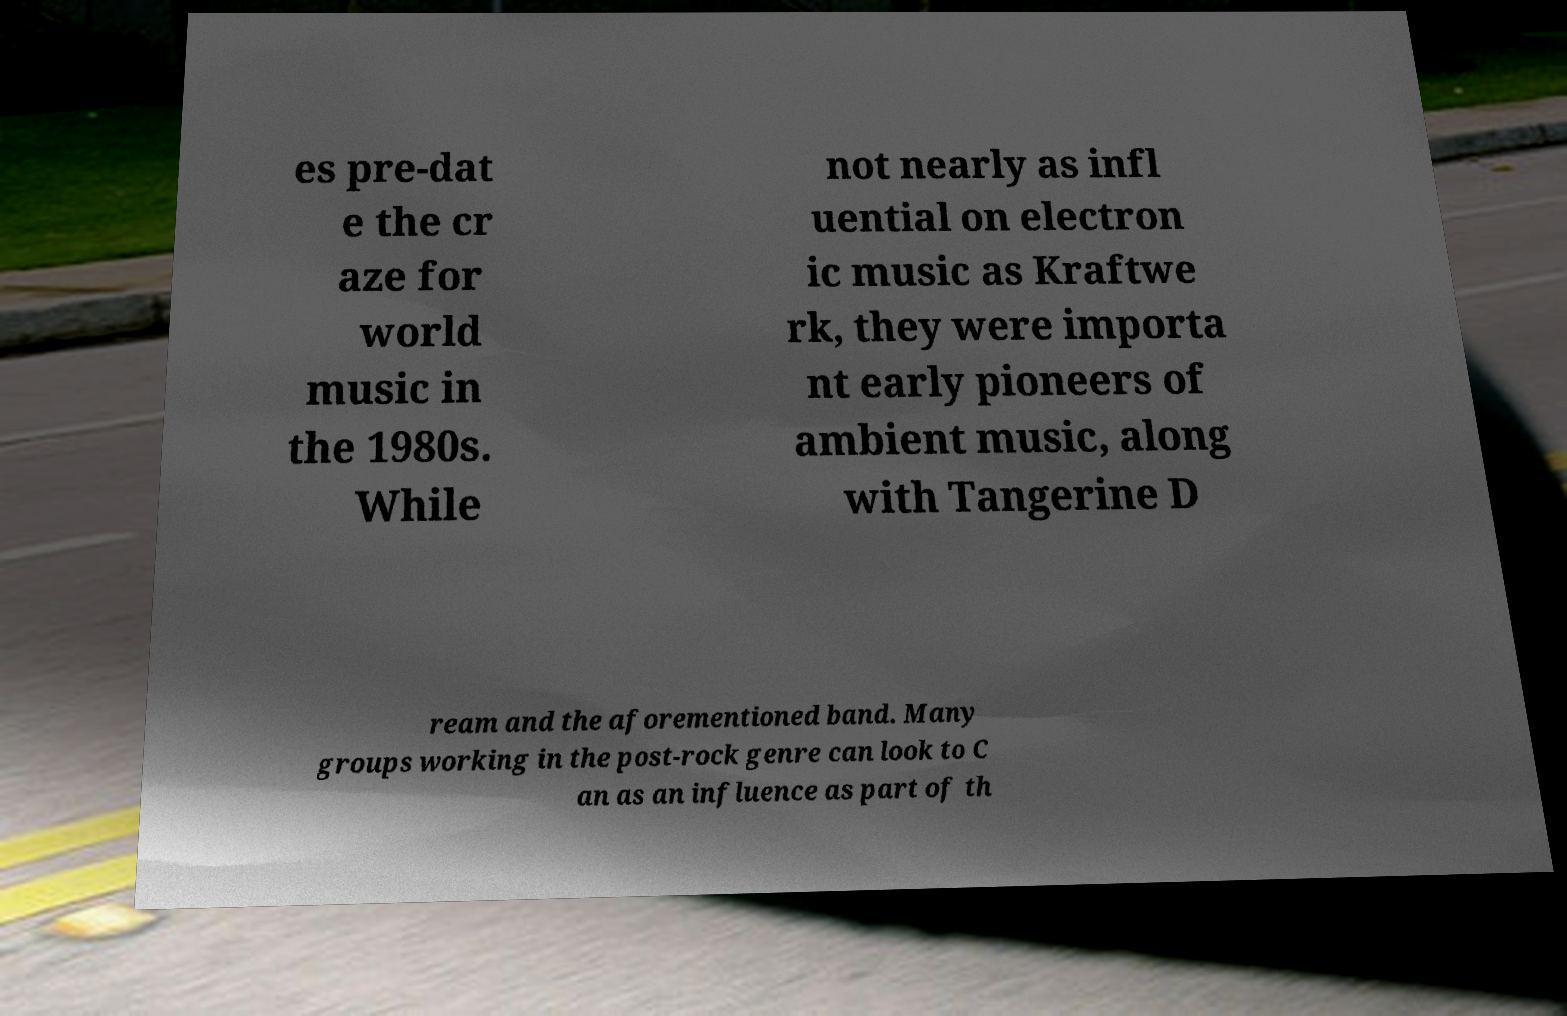Please identify and transcribe the text found in this image. es pre-dat e the cr aze for world music in the 1980s. While not nearly as infl uential on electron ic music as Kraftwe rk, they were importa nt early pioneers of ambient music, along with Tangerine D ream and the aforementioned band. Many groups working in the post-rock genre can look to C an as an influence as part of th 